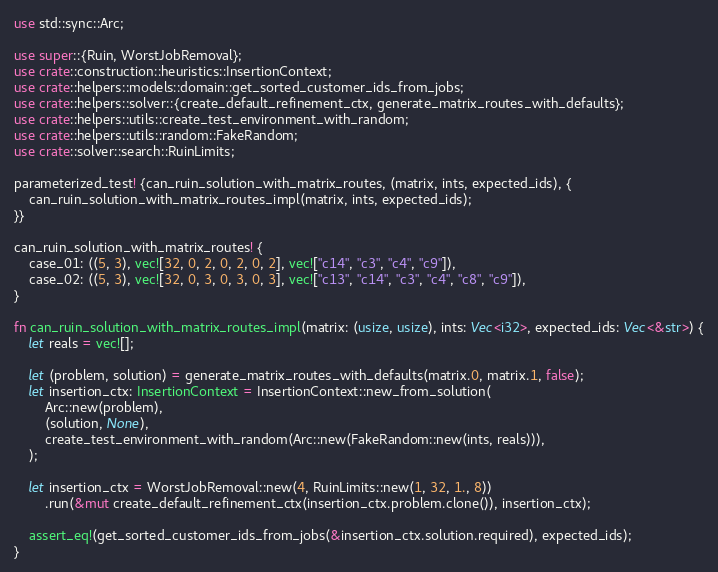Convert code to text. <code><loc_0><loc_0><loc_500><loc_500><_Rust_>use std::sync::Arc;

use super::{Ruin, WorstJobRemoval};
use crate::construction::heuristics::InsertionContext;
use crate::helpers::models::domain::get_sorted_customer_ids_from_jobs;
use crate::helpers::solver::{create_default_refinement_ctx, generate_matrix_routes_with_defaults};
use crate::helpers::utils::create_test_environment_with_random;
use crate::helpers::utils::random::FakeRandom;
use crate::solver::search::RuinLimits;

parameterized_test! {can_ruin_solution_with_matrix_routes, (matrix, ints, expected_ids), {
    can_ruin_solution_with_matrix_routes_impl(matrix, ints, expected_ids);
}}

can_ruin_solution_with_matrix_routes! {
    case_01: ((5, 3), vec![32, 0, 2, 0, 2, 0, 2], vec!["c14", "c3", "c4", "c9"]),
    case_02: ((5, 3), vec![32, 0, 3, 0, 3, 0, 3], vec!["c13", "c14", "c3", "c4", "c8", "c9"]),
}

fn can_ruin_solution_with_matrix_routes_impl(matrix: (usize, usize), ints: Vec<i32>, expected_ids: Vec<&str>) {
    let reals = vec![];

    let (problem, solution) = generate_matrix_routes_with_defaults(matrix.0, matrix.1, false);
    let insertion_ctx: InsertionContext = InsertionContext::new_from_solution(
        Arc::new(problem),
        (solution, None),
        create_test_environment_with_random(Arc::new(FakeRandom::new(ints, reals))),
    );

    let insertion_ctx = WorstJobRemoval::new(4, RuinLimits::new(1, 32, 1., 8))
        .run(&mut create_default_refinement_ctx(insertion_ctx.problem.clone()), insertion_ctx);

    assert_eq!(get_sorted_customer_ids_from_jobs(&insertion_ctx.solution.required), expected_ids);
}
</code> 